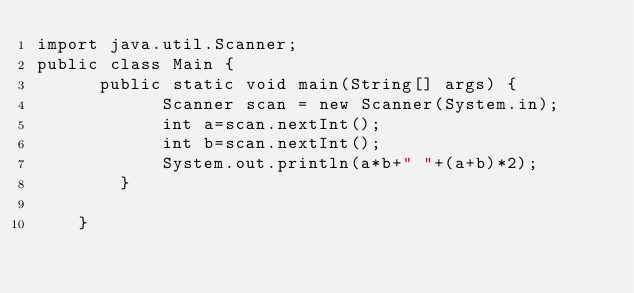<code> <loc_0><loc_0><loc_500><loc_500><_Java_>import java.util.Scanner;
public class Main {
	  public static void main(String[] args) {
	        Scanner scan = new Scanner(System.in);
	        int a=scan.nextInt();
	        int b=scan.nextInt();
	        System.out.println(a*b+" "+(a+b)*2);
	    }
	    
	}

</code> 